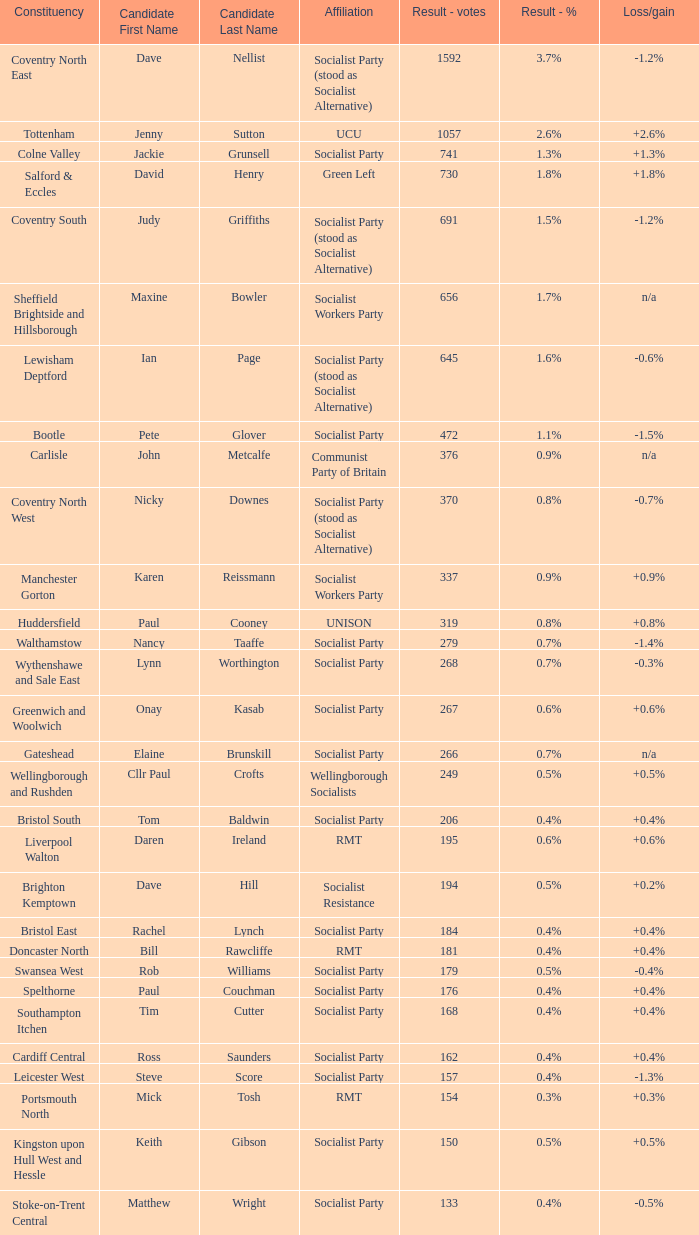What is every candidate for the Cardiff Central constituency? Ross Saunders. 